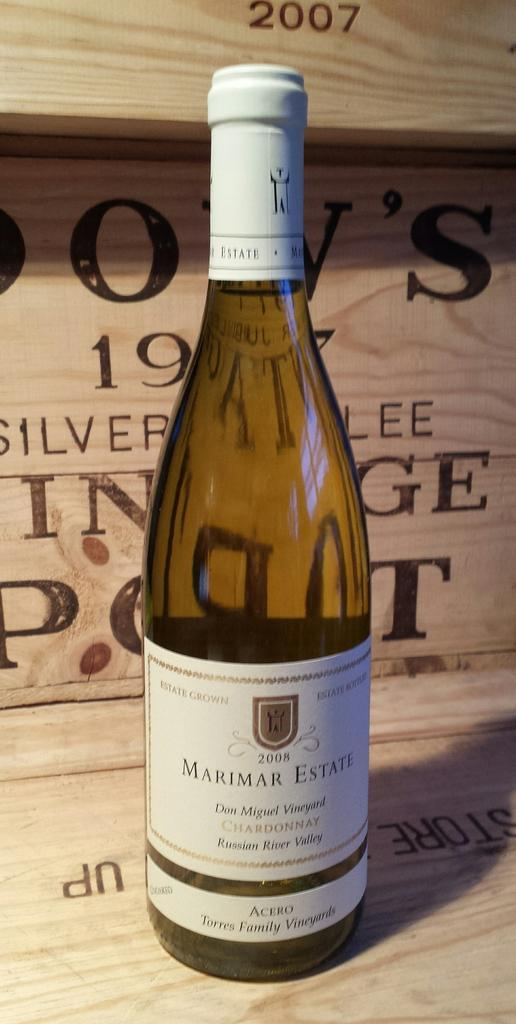<image>
Share a concise interpretation of the image provided. A clear bottle with a white label that reads Marimar Estate on the center of it. 